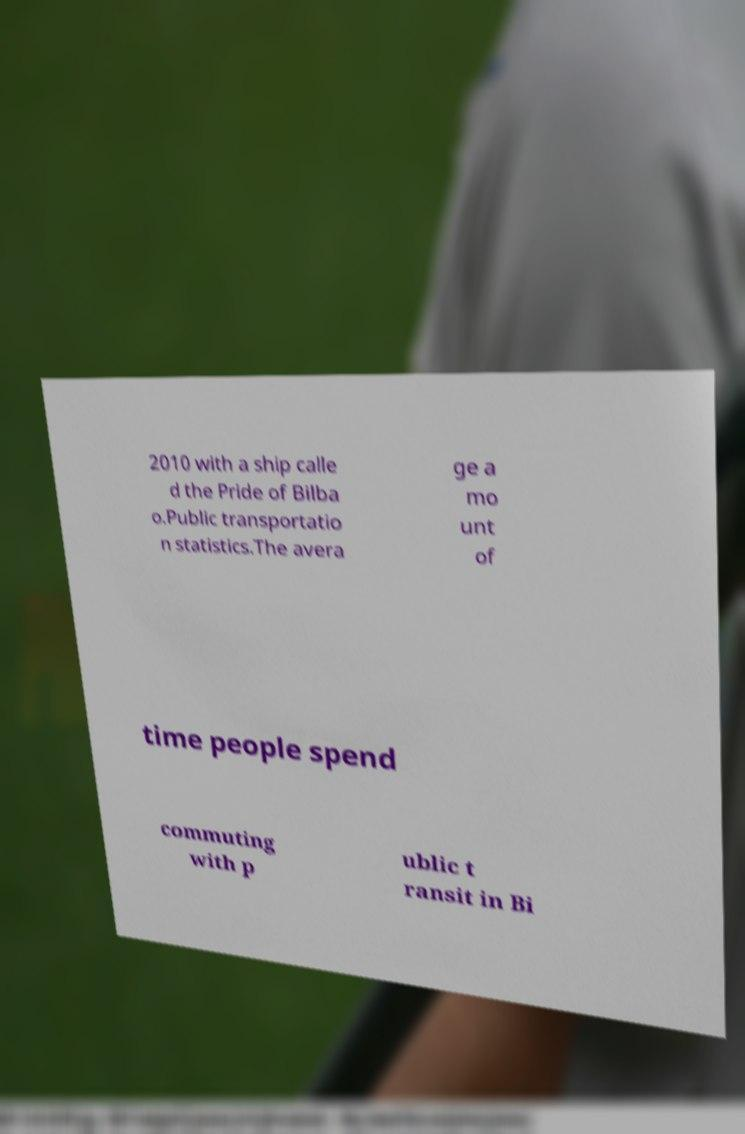Could you extract and type out the text from this image? 2010 with a ship calle d the Pride of Bilba o.Public transportatio n statistics.The avera ge a mo unt of time people spend commuting with p ublic t ransit in Bi 